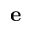<formula> <loc_0><loc_0><loc_500><loc_500>e</formula> 